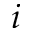Convert formula to latex. <formula><loc_0><loc_0><loc_500><loc_500>i</formula> 